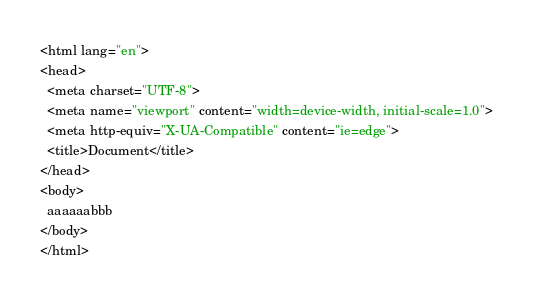<code> <loc_0><loc_0><loc_500><loc_500><_HTML_><html lang="en">
<head>
  <meta charset="UTF-8">
  <meta name="viewport" content="width=device-width, initial-scale=1.0">
  <meta http-equiv="X-UA-Compatible" content="ie=edge">
  <title>Document</title>
</head>
<body>
  aaaaaabbb
</body>
</html></code> 